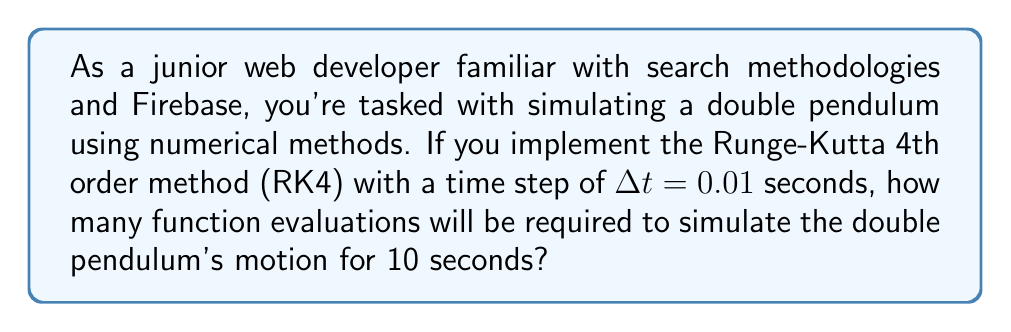Teach me how to tackle this problem. Let's approach this step-by-step:

1) The Runge-Kutta 4th order method (RK4) requires 4 function evaluations per time step.

2) We need to calculate the number of time steps in our simulation:
   
   Total time = 10 seconds
   Time step ($\Delta t$) = 0.01 seconds
   
   Number of steps = $\frac{\text{Total time}}{\Delta t} = \frac{10}{0.01} = 1000$ steps

3) For each step, RK4 performs 4 function evaluations.

4) Therefore, the total number of function evaluations is:
   
   Total evaluations = Number of steps × Evaluations per step
                     = $1000 \times 4 = 4000$

Thus, 4000 function evaluations will be required to simulate the double pendulum's motion for 10 seconds using RK4 with a time step of 0.01 seconds.
Answer: 4000 function evaluations 